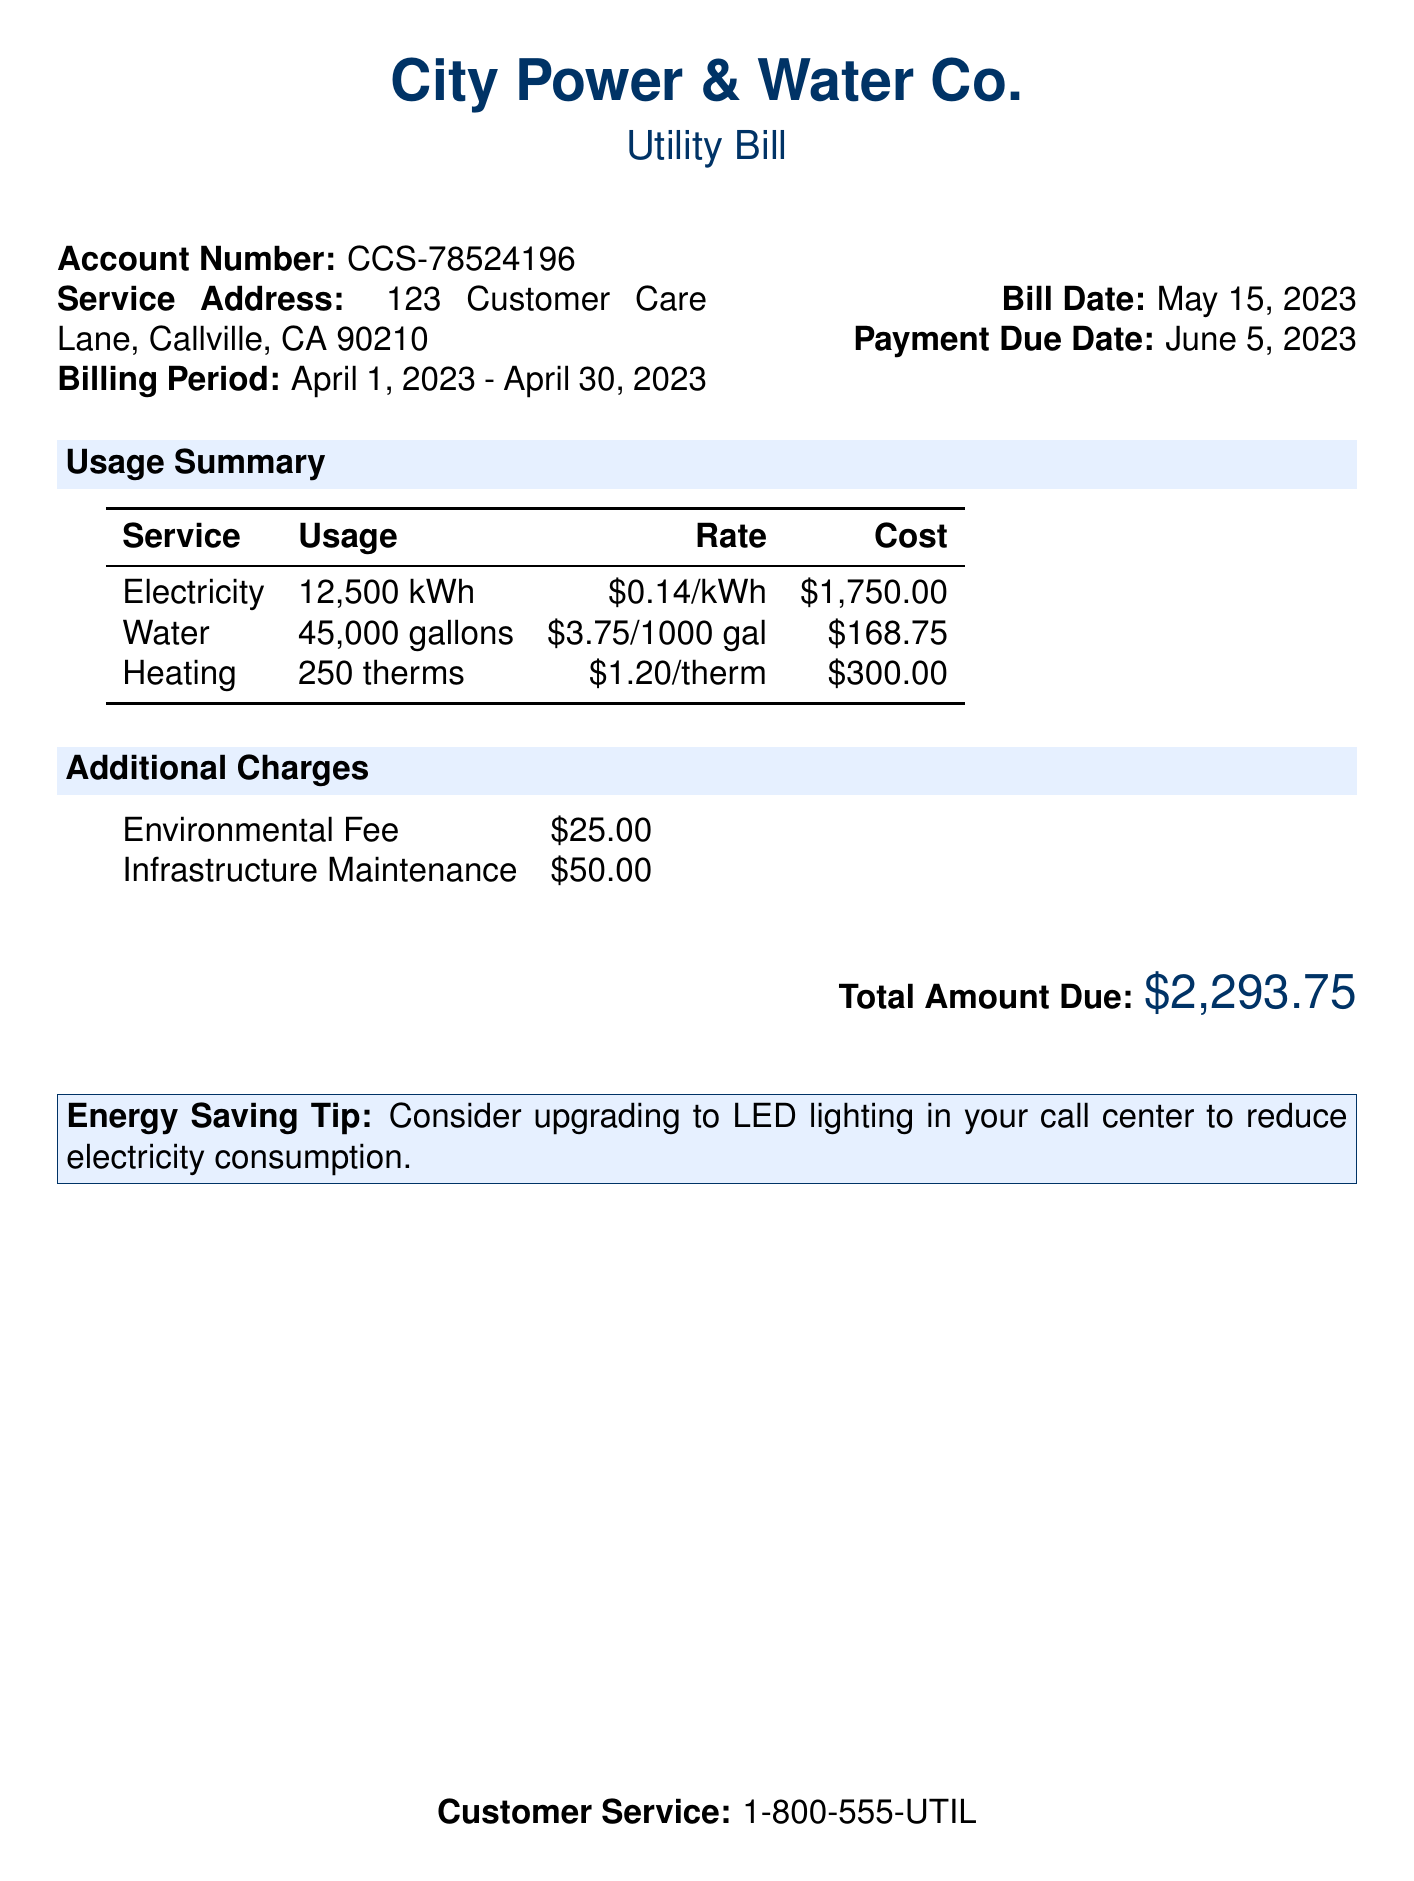What is the account number? The account number is stated near the top of the document under the account details.
Answer: CCS-78524196 What is the billing period? The billing period specifies the time frame for which the services were provided; it is found in the account details section.
Answer: April 1, 2023 - April 30, 2023 How much did the electricity usage cost? The electricity cost is calculated based on the given usage and rate, which is detailed in the usage summary.
Answer: $1,750.00 What is the total amount due? The total amount due is listed at the bottom of the bill, summarizing all costs.
Answer: $2,293.75 What service used 45,000 gallons? The amount 45,000 gallons is specifically mentioned in the usage summary corresponding to a type of service.
Answer: Water What is the rate for heating? The rate for heating per therm is provided in the usage summary section of the bill.
Answer: $1.20/therm What additional fee is listed? The document includes additional fees for services, which are specified in their own section.
Answer: Infrastructure Maintenance What is the contact number for customer service? The customer service contact information is provided at the end of the document for further assistance.
Answer: 1-800-555-UTIL 